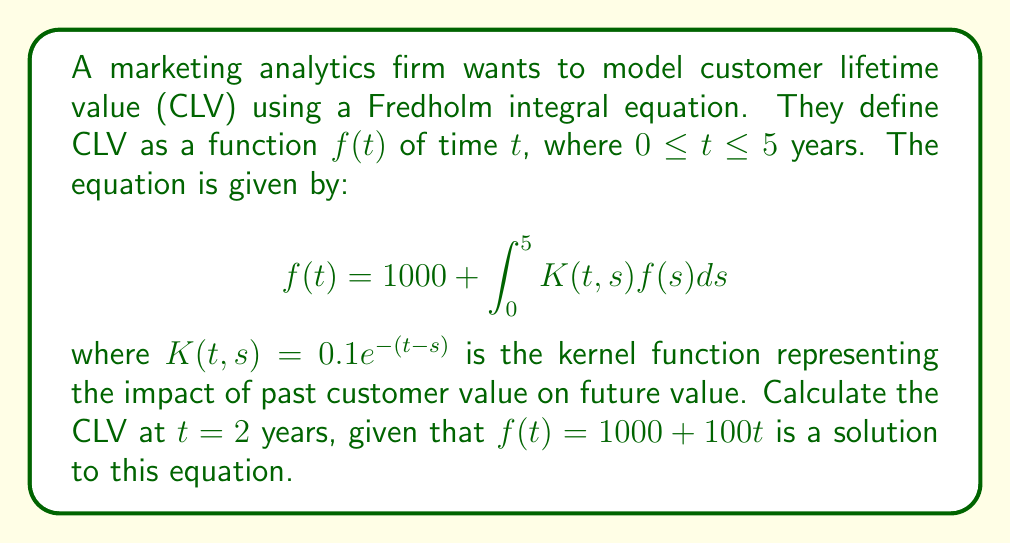What is the answer to this math problem? To solve this problem, we'll follow these steps:

1) We're given that $f(t) = 1000 + 100t$ is a solution to the Fredholm integral equation.

2) To find the CLV at $t=2$ years, we simply need to substitute $t=2$ into this function:

   $f(2) = 1000 + 100(2)$

3) Let's calculate:

   $f(2) = 1000 + 200 = 1200$

4) To verify this solution, we can substitute it back into the original equation:

   $$f(t) = 1000 + \int_0^5 0.1e^{-(t-s)}(1000 + 100s)ds$$

5) However, this verification is not necessary for answering the question at hand.

6) The CLV at $t=2$ years is $1200.

This approach demonstrates how the Fredholm integral equation can be used to model complex business metrics like CLV, accounting for the time-dependent nature of customer value.
Answer: $1200 